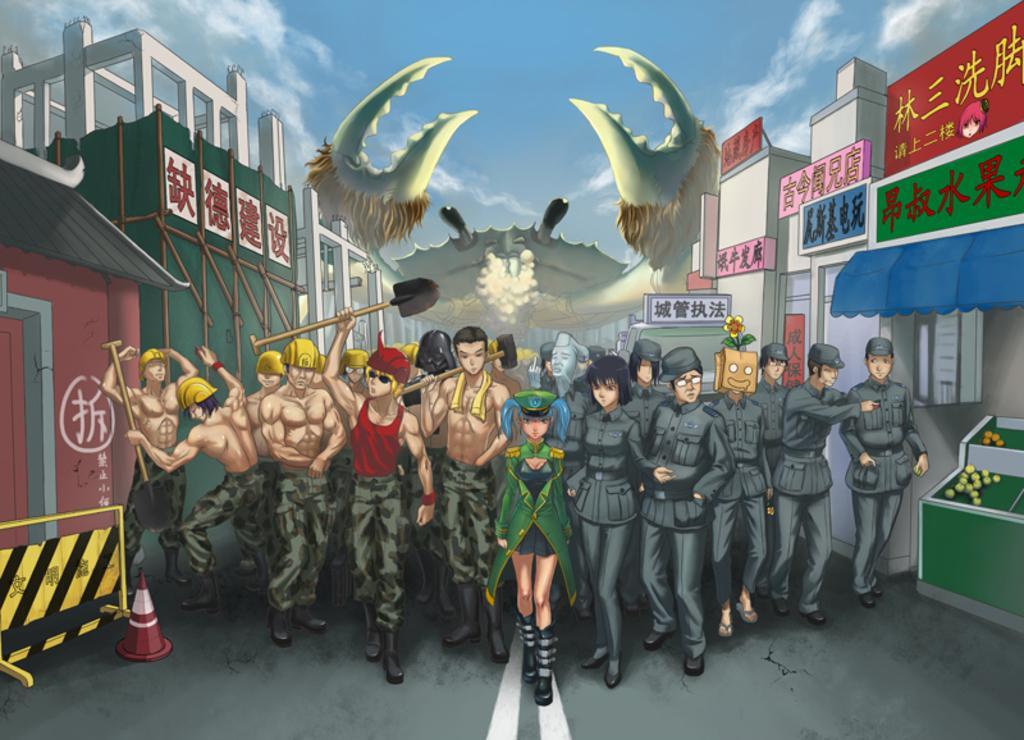Please provide a concise description of this image. This is an animated picture. Few persons are standing on the road. Left side there is a fence. Before it there is an inverted cone on the road. Few persons are holding the tools in their hands. Few persons are wearing helmets. Background there are few buildings. Middle of the image there is an animal. Top of the image there is sky. Right side there is a table having few objects on it. 